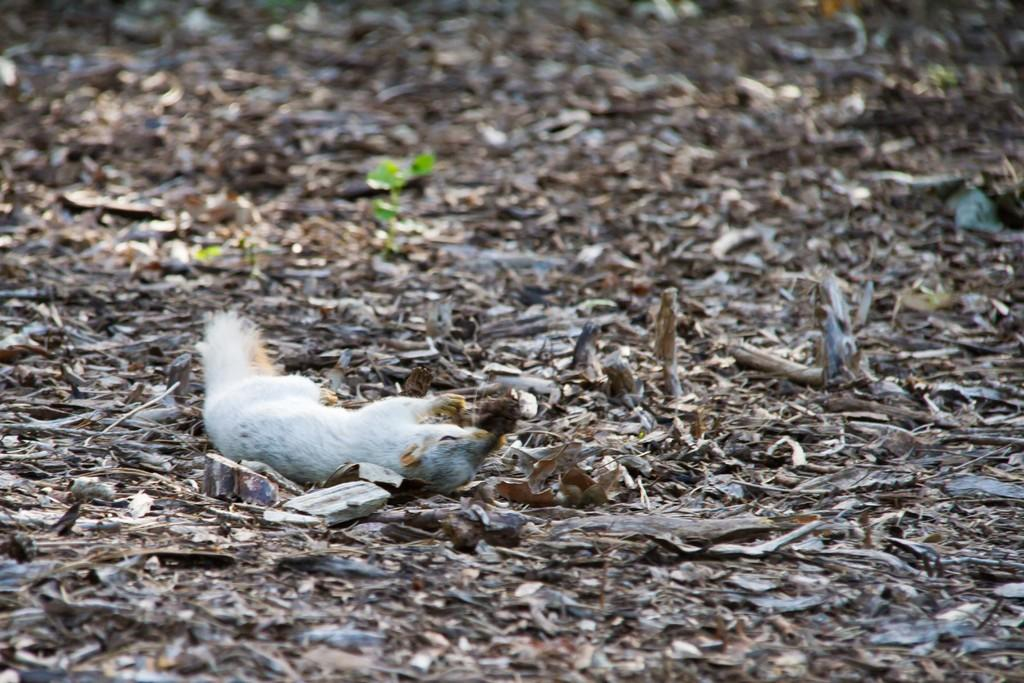What type of animal is in the image? There is a squirrel in the image. Where is the squirrel located in the image? The squirrel is on the left side of the image. What type of decision is the squirrel making in the image? There is no indication in the image that the squirrel is making any decisions. What type of fruit is the squirrel holding in the image? There is no fruit present in the image, and the squirrel is not holding anything. 